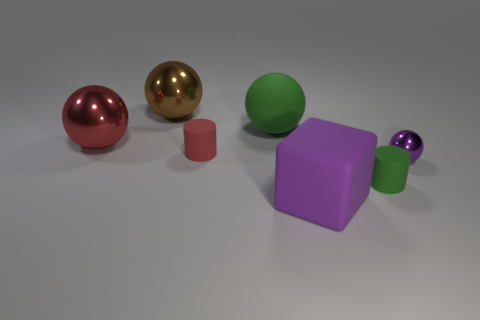Subtract all large spheres. How many spheres are left? 1 Subtract all green balls. How many balls are left? 3 Subtract all gray balls. Subtract all purple cubes. How many balls are left? 4 Add 1 rubber cylinders. How many objects exist? 8 Subtract all spheres. How many objects are left? 3 Add 6 green cylinders. How many green cylinders exist? 7 Subtract 0 purple cylinders. How many objects are left? 7 Subtract all large green matte balls. Subtract all tiny purple metallic balls. How many objects are left? 5 Add 3 rubber things. How many rubber things are left? 7 